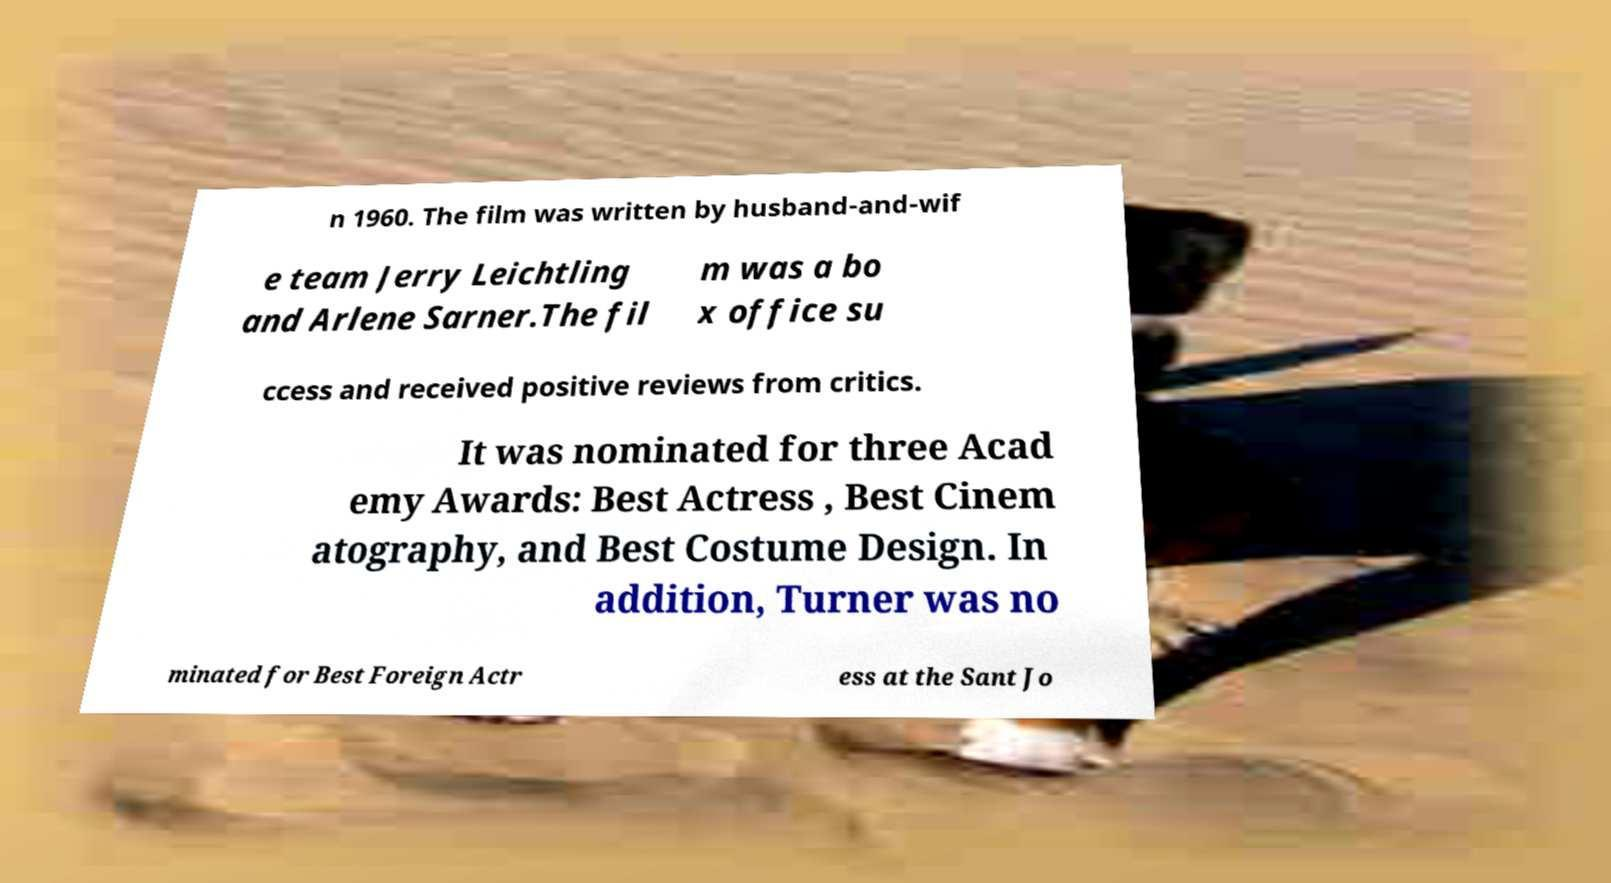Please identify and transcribe the text found in this image. n 1960. The film was written by husband-and-wif e team Jerry Leichtling and Arlene Sarner.The fil m was a bo x office su ccess and received positive reviews from critics. It was nominated for three Acad emy Awards: Best Actress , Best Cinem atography, and Best Costume Design. In addition, Turner was no minated for Best Foreign Actr ess at the Sant Jo 